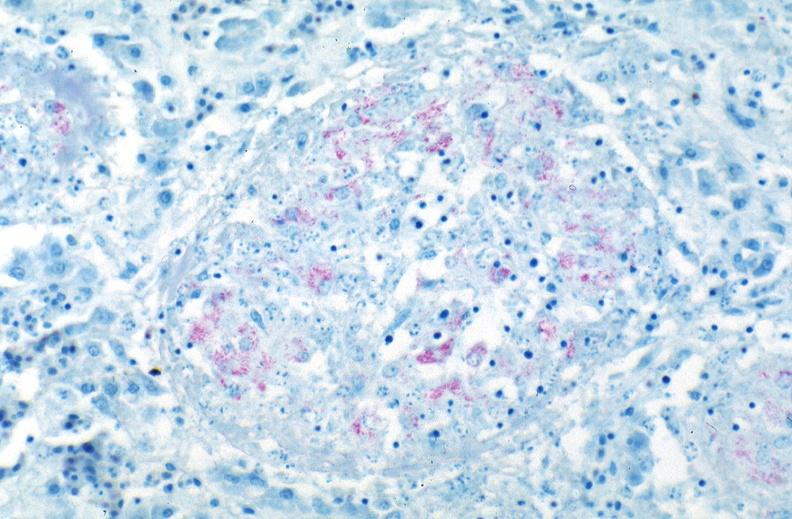does this image show lung, mycobacterium tuberculosis, acid fast?
Answer the question using a single word or phrase. Yes 